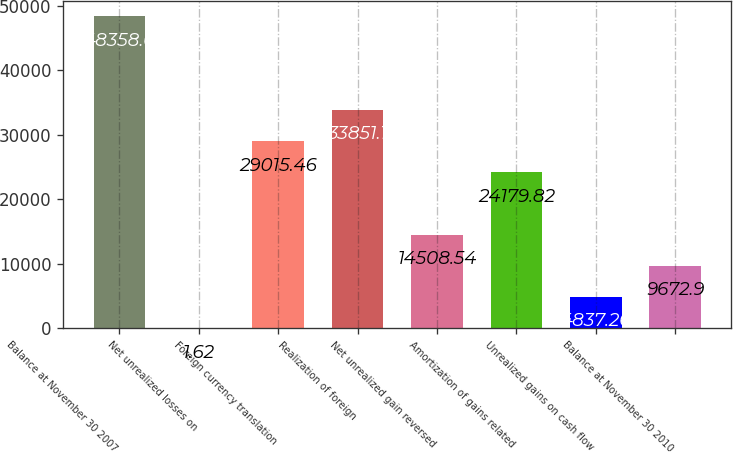Convert chart. <chart><loc_0><loc_0><loc_500><loc_500><bar_chart><fcel>Balance at November 30 2007<fcel>Net unrealized losses on<fcel>Foreign currency translation<fcel>Realization of foreign<fcel>Net unrealized gain reversed<fcel>Amortization of gains related<fcel>Unrealized gains on cash flow<fcel>Balance at November 30 2010<nl><fcel>48358<fcel>1.62<fcel>29015.5<fcel>33851.1<fcel>14508.5<fcel>24179.8<fcel>4837.26<fcel>9672.9<nl></chart> 